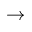Convert formula to latex. <formula><loc_0><loc_0><loc_500><loc_500>\to</formula> 